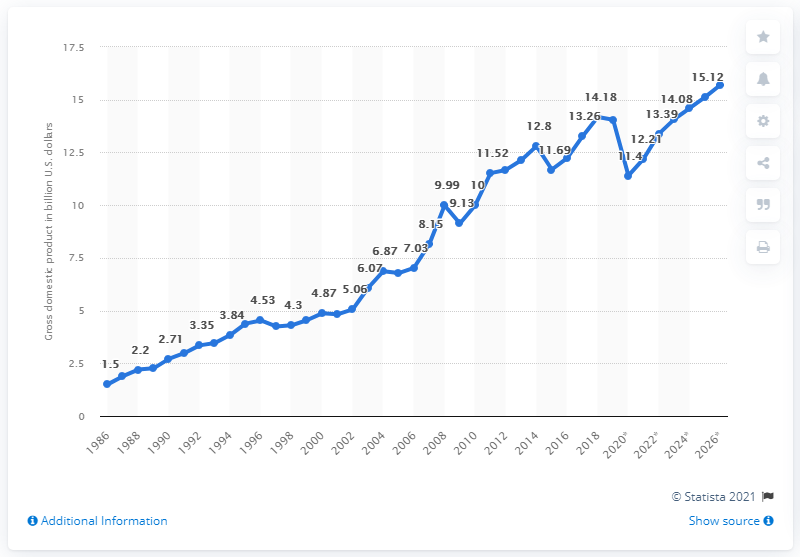Draw attention to some important aspects in this diagram. In 2018, the gross domestic product of Mauritius was 14.08 billion dollars. 